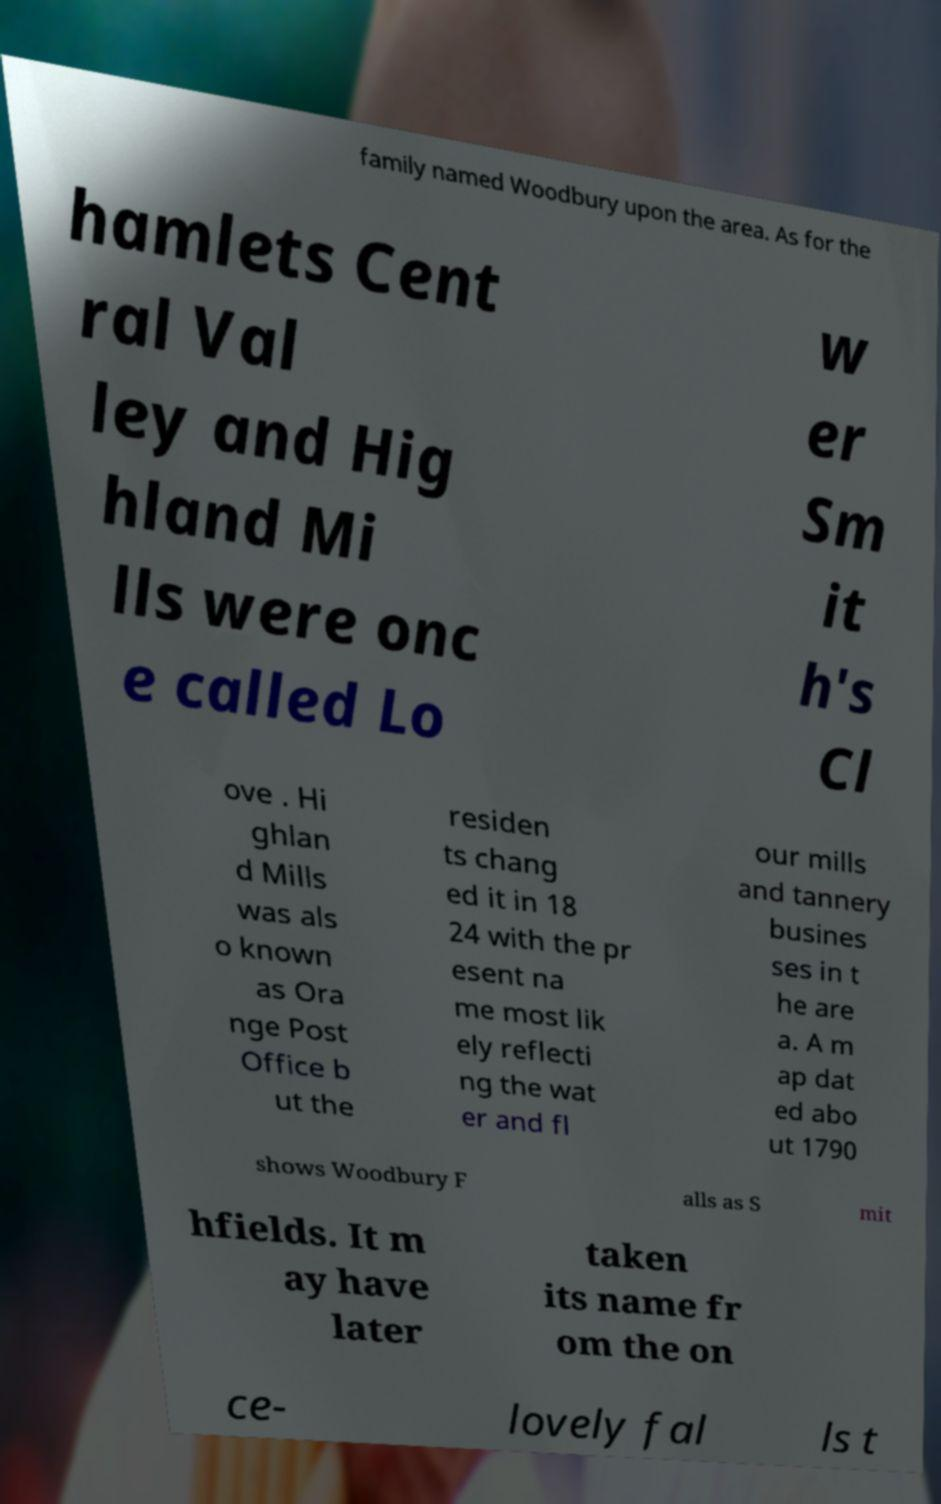Could you assist in decoding the text presented in this image and type it out clearly? family named Woodbury upon the area. As for the hamlets Cent ral Val ley and Hig hland Mi lls were onc e called Lo w er Sm it h's Cl ove . Hi ghlan d Mills was als o known as Ora nge Post Office b ut the residen ts chang ed it in 18 24 with the pr esent na me most lik ely reflecti ng the wat er and fl our mills and tannery busines ses in t he are a. A m ap dat ed abo ut 1790 shows Woodbury F alls as S mit hfields. It m ay have later taken its name fr om the on ce- lovely fal ls t 